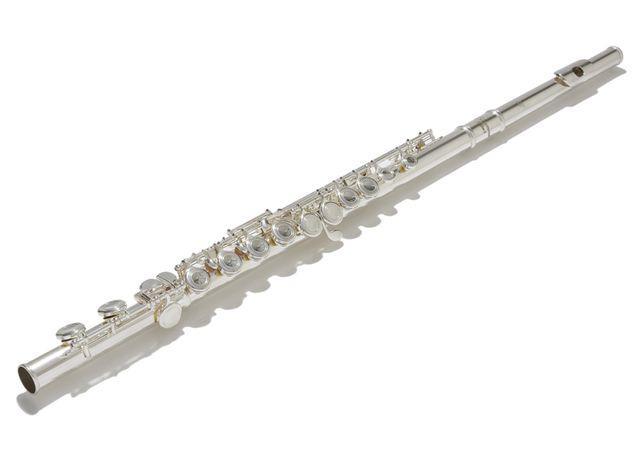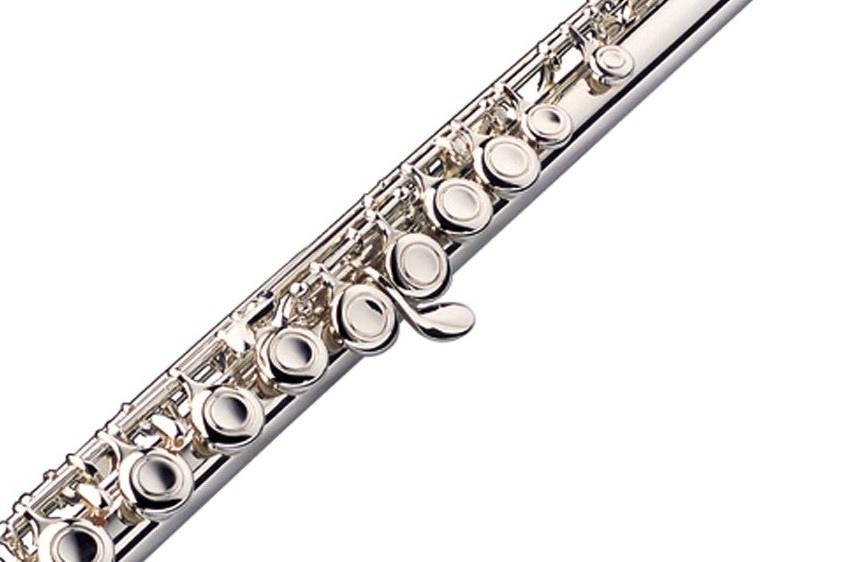The first image is the image on the left, the second image is the image on the right. Analyze the images presented: Is the assertion "Each image contains exactly one dark flute with metal keys." valid? Answer yes or no. No. The first image is the image on the left, the second image is the image on the right. For the images displayed, is the sentence "There are two very dark colored flutes." factually correct? Answer yes or no. No. 